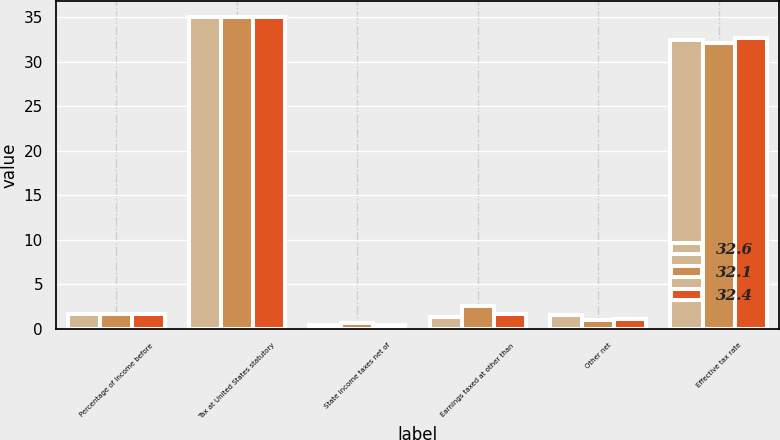Convert chart. <chart><loc_0><loc_0><loc_500><loc_500><stacked_bar_chart><ecel><fcel>Percentage of Income before<fcel>Tax at United States statutory<fcel>State income taxes net of<fcel>Earnings taxed at other than<fcel>Other net<fcel>Effective tax rate<nl><fcel>32.6<fcel>1.7<fcel>35<fcel>0.4<fcel>1.4<fcel>1.6<fcel>32.4<nl><fcel>32.1<fcel>1.7<fcel>35<fcel>0.7<fcel>2.6<fcel>1<fcel>32.1<nl><fcel>32.4<fcel>1.7<fcel>35<fcel>0.4<fcel>1.7<fcel>1.1<fcel>32.6<nl></chart> 